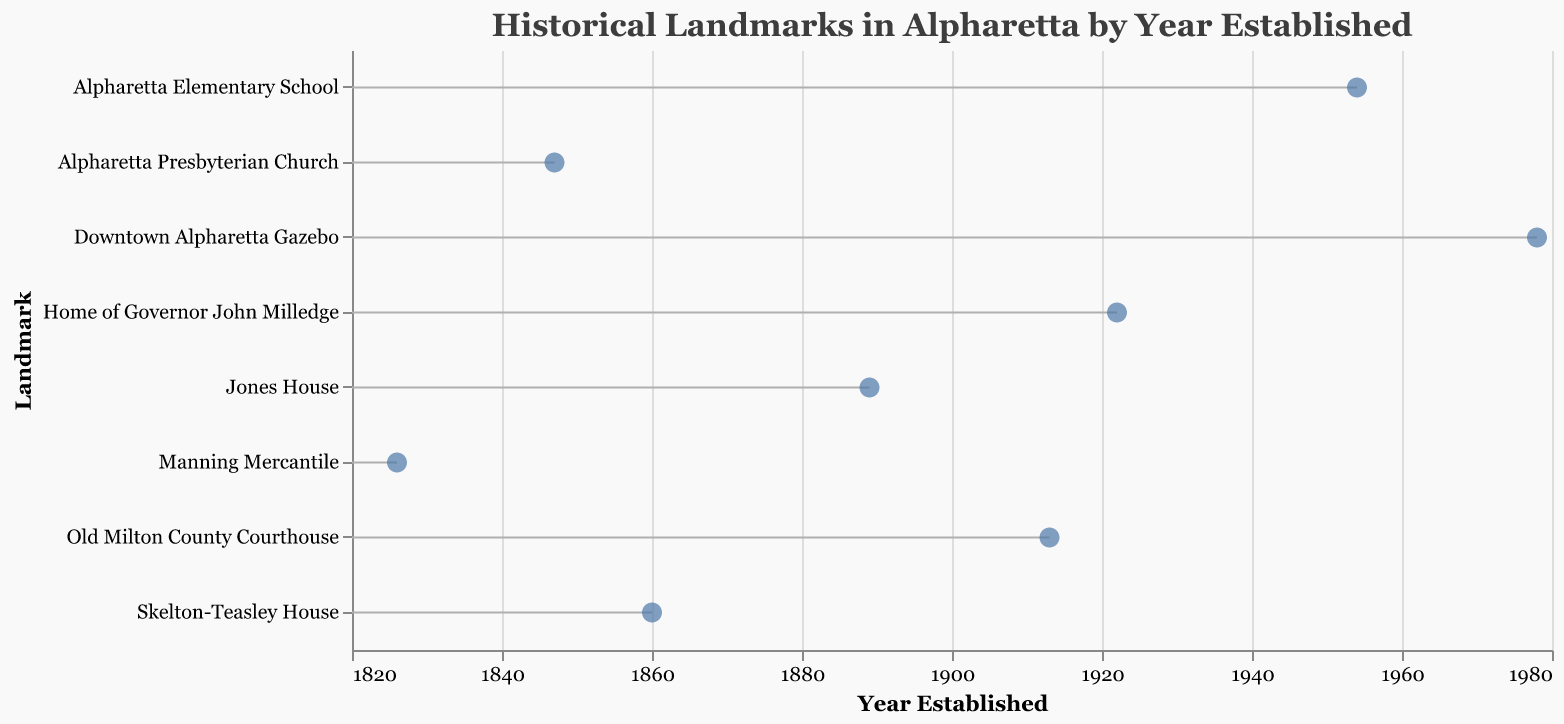How many historical landmarks are established in Alpharetta according to the plot? By counting the number of data points in the plot, we see that there are eight landmarks established in Alpharetta.
Answer: Eight What is the earliest decade featured in the plot? The earliest decade can be observed by looking at the leftmost data point representing the decade when landmarks were established. The earliest decade shown is the 1820s.
Answer: 1820s Which landmark was established in the 1920s? By looking at the position of data points along the x-axis (Year Established), we can identify which landmark corresponds to the 1920s. The "Home of Governor John Milledge" was established in the 1920s.
Answer: Home of Governor John Milledge Can you list at least three landmarks established before the 1900s? By checking the x-axis (Year Established) and identifying landmarks with years before 1900, we find:
1. Manning Mercantile (1826)
2. Alpharetta Presbyterian Church (1847)
3. Skelton-Teasley House (1860)
4. Jones House (1889)
Answer: Manning Mercantile, Alpharetta Presbyterian Church, Skelton-Teasley House, Jones House What is the latest decade covered by the plot? By identifying the rightmost data point on the x-axis (Year Established), the latest decade presented is the 1970s.
Answer: 1970s Which landmark was established in the 1860s? By matching the decade to the specific year established along the x-axis, we find that the "Skelton-Teasley House" was established in the 1860s.
Answer: Skelton-Teasley House Which landmark was established most recently according to the plot? The latest established landmark is represented by the rightmost data point along the x-axis. It is the "Downtown Alpharetta Gazebo," established in 1978.
Answer: Downtown Alpharetta Gazebo What’s the range of years for all landmarks established in Alpharetta according to the plot? By identifying the earliest and most recent years along the x-axis (Year Established), we see the range is from 1826 to 1978.
Answer: 1826 to 1978 How many landmarks were established in the 1800s? By checking the x-axis for years within the range of the 1800s, we count four landmarks: 
1. Manning Mercantile (1826)
2. Alpharetta Presbyterian Church (1847)
3. Skelton-Teasley House (1860)
4. Jones House (1889)
Answer: Four Compare the number of landmarks established by 1900 to those established after 1900. Which period saw more landmarks established? By counting the landmarks established before and after 1900: 
1. Before 1900: Manning Mercantile, Alpharetta Presbyterian Church, Skelton-Teasley House, Jones House (4 landmarks)
2. After 1900: Old Milton County Courthouse, Home of Governor John Milledge, Alpharetta Elementary School, Downtown Alpharetta Gazebo (4 landmarks) 
Both periods saw an equal number of landmarks established.
Answer: Equal 